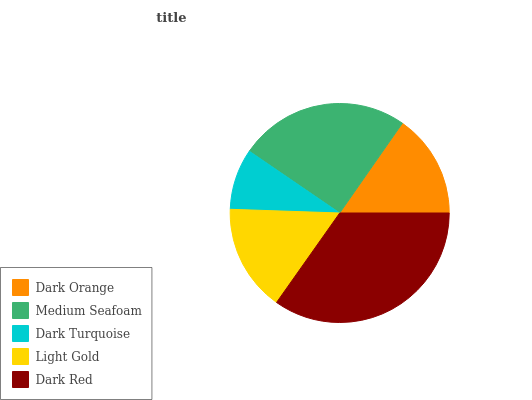Is Dark Turquoise the minimum?
Answer yes or no. Yes. Is Dark Red the maximum?
Answer yes or no. Yes. Is Medium Seafoam the minimum?
Answer yes or no. No. Is Medium Seafoam the maximum?
Answer yes or no. No. Is Medium Seafoam greater than Dark Orange?
Answer yes or no. Yes. Is Dark Orange less than Medium Seafoam?
Answer yes or no. Yes. Is Dark Orange greater than Medium Seafoam?
Answer yes or no. No. Is Medium Seafoam less than Dark Orange?
Answer yes or no. No. Is Light Gold the high median?
Answer yes or no. Yes. Is Light Gold the low median?
Answer yes or no. Yes. Is Dark Turquoise the high median?
Answer yes or no. No. Is Dark Turquoise the low median?
Answer yes or no. No. 